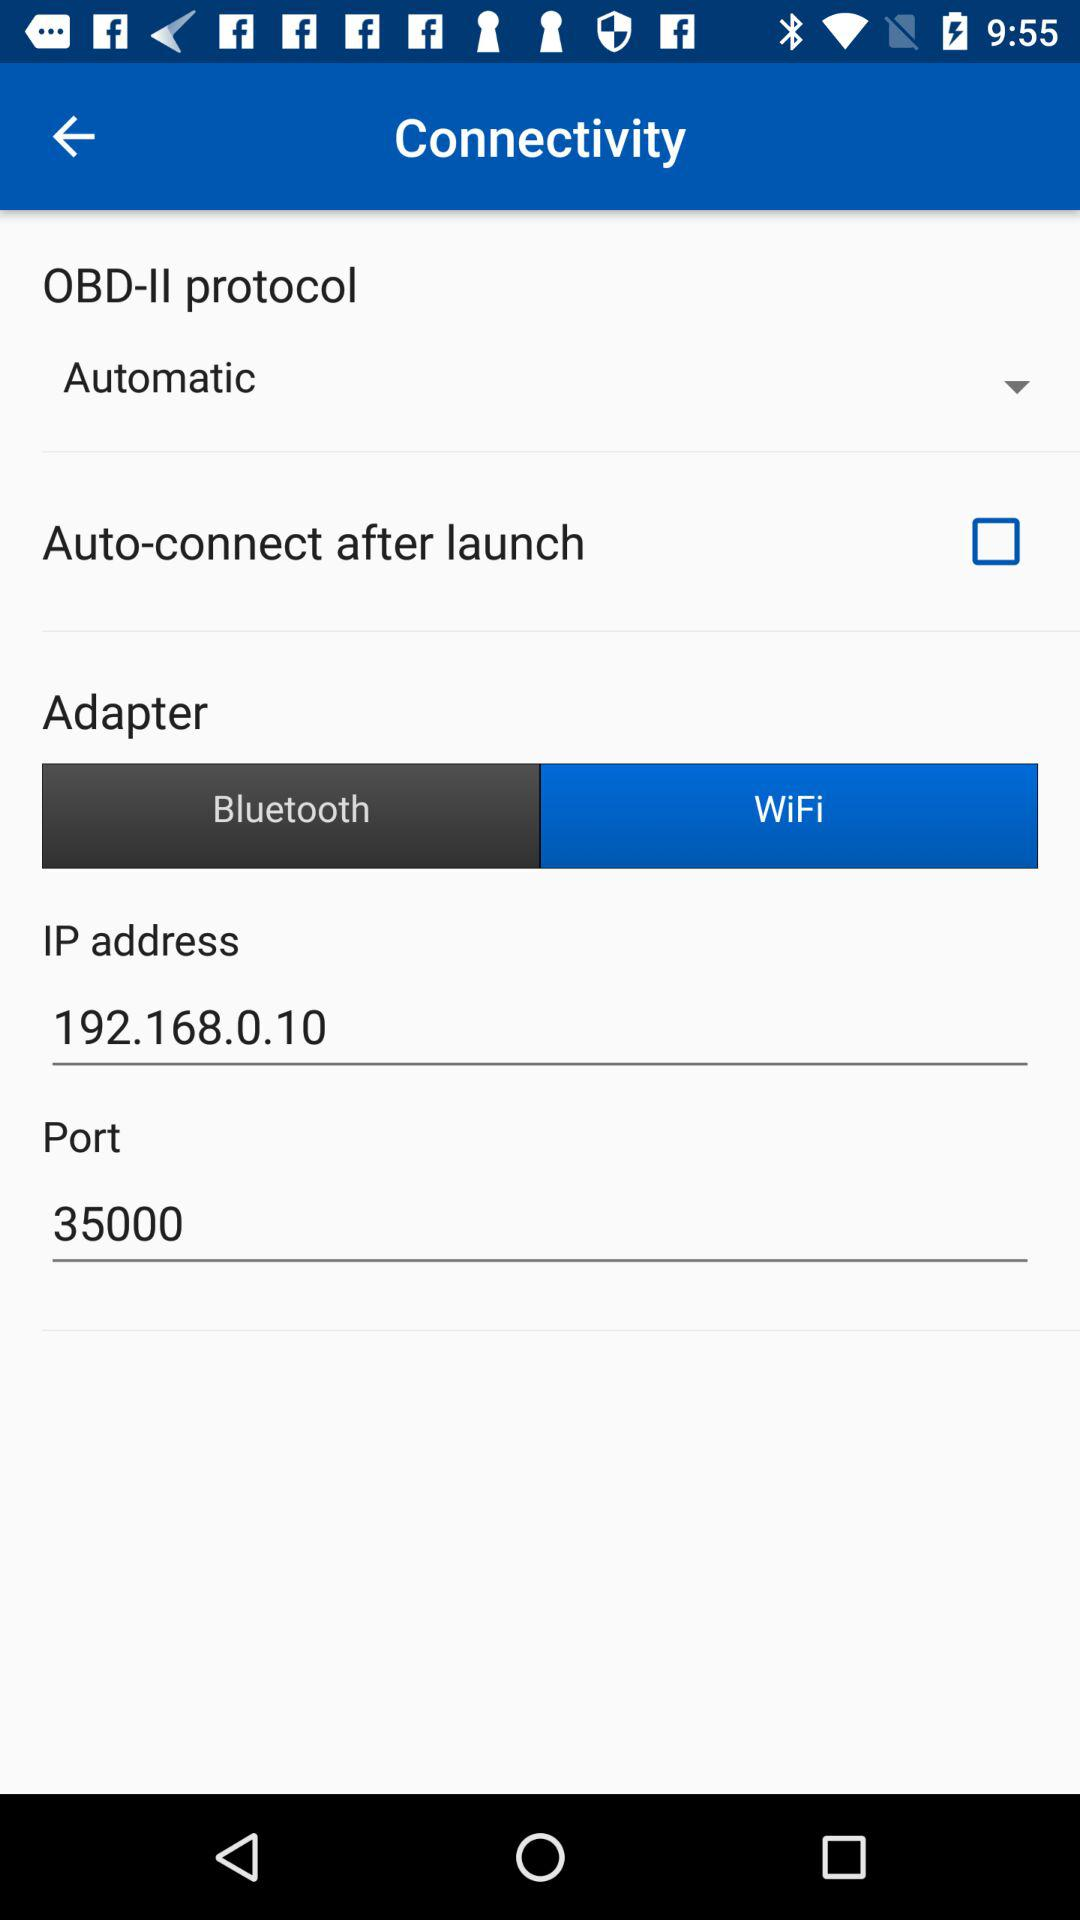What is the IP address? The IP address is 192.168.0.10. 